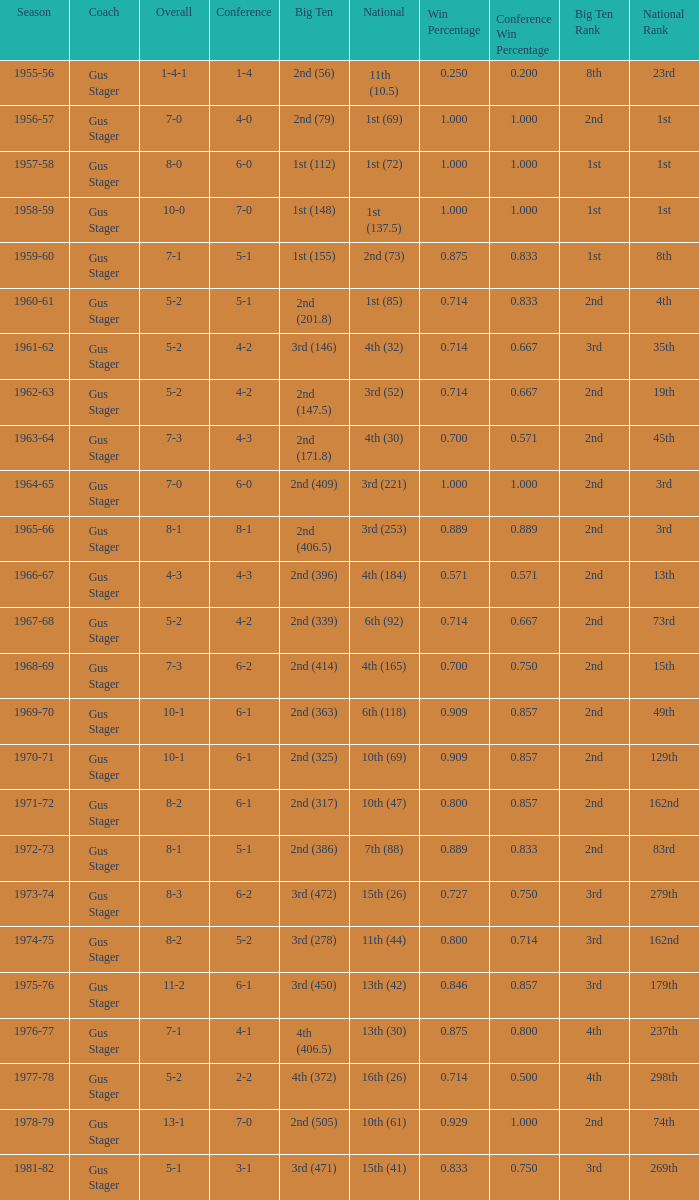What is the Season with a Big Ten that is 2nd (386)? 1972-73. 